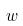Convert formula to latex. <formula><loc_0><loc_0><loc_500><loc_500>w</formula> 